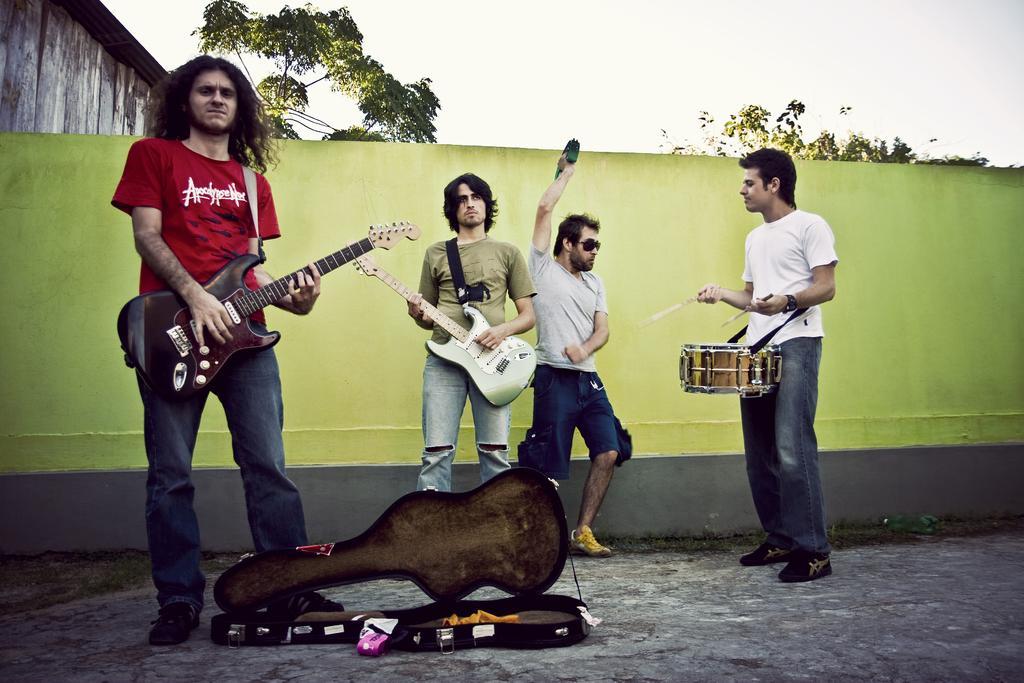How would you summarize this image in a sentence or two? This is a picture of a band. In the foreground of the picture there are four people. On the left a man in red t-shirt is playing guitar. In the center a man is playing guitar. On the right a man is playing drum. In the center a man is dancing. In the foreground there is a guitar box. In the center there is a green wall. In the background there are trees and building. Sky is cloudy. 